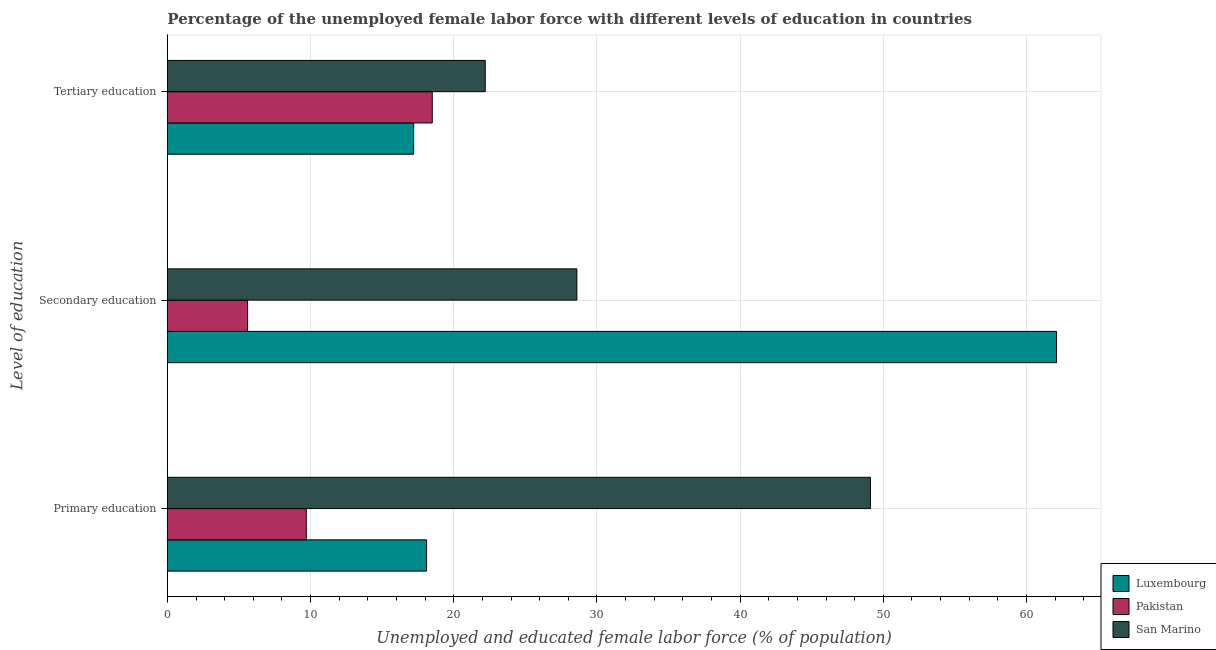How many groups of bars are there?
Your answer should be very brief. 3. Are the number of bars on each tick of the Y-axis equal?
Your answer should be very brief. Yes. What is the label of the 2nd group of bars from the top?
Give a very brief answer. Secondary education. What is the percentage of female labor force who received secondary education in San Marino?
Offer a very short reply. 28.6. Across all countries, what is the maximum percentage of female labor force who received secondary education?
Provide a succinct answer. 62.1. Across all countries, what is the minimum percentage of female labor force who received primary education?
Your answer should be compact. 9.7. In which country was the percentage of female labor force who received primary education maximum?
Provide a succinct answer. San Marino. In which country was the percentage of female labor force who received tertiary education minimum?
Ensure brevity in your answer.  Luxembourg. What is the total percentage of female labor force who received tertiary education in the graph?
Provide a short and direct response. 57.9. What is the difference between the percentage of female labor force who received secondary education in Luxembourg and that in Pakistan?
Provide a succinct answer. 56.5. What is the difference between the percentage of female labor force who received primary education in Pakistan and the percentage of female labor force who received secondary education in San Marino?
Your answer should be compact. -18.9. What is the average percentage of female labor force who received primary education per country?
Offer a very short reply. 25.63. What is the difference between the percentage of female labor force who received secondary education and percentage of female labor force who received primary education in Luxembourg?
Offer a very short reply. 44. What is the ratio of the percentage of female labor force who received secondary education in San Marino to that in Pakistan?
Keep it short and to the point. 5.11. Is the difference between the percentage of female labor force who received secondary education in Pakistan and San Marino greater than the difference between the percentage of female labor force who received primary education in Pakistan and San Marino?
Ensure brevity in your answer.  Yes. What is the difference between the highest and the second highest percentage of female labor force who received primary education?
Ensure brevity in your answer.  31. What is the difference between the highest and the lowest percentage of female labor force who received primary education?
Provide a succinct answer. 39.4. What does the 3rd bar from the top in Primary education represents?
Provide a succinct answer. Luxembourg. What does the 3rd bar from the bottom in Tertiary education represents?
Offer a very short reply. San Marino. Is it the case that in every country, the sum of the percentage of female labor force who received primary education and percentage of female labor force who received secondary education is greater than the percentage of female labor force who received tertiary education?
Offer a terse response. No. How many bars are there?
Ensure brevity in your answer.  9. How many countries are there in the graph?
Give a very brief answer. 3. What is the difference between two consecutive major ticks on the X-axis?
Provide a succinct answer. 10. Does the graph contain any zero values?
Your response must be concise. No. What is the title of the graph?
Provide a short and direct response. Percentage of the unemployed female labor force with different levels of education in countries. Does "French Polynesia" appear as one of the legend labels in the graph?
Offer a terse response. No. What is the label or title of the X-axis?
Offer a terse response. Unemployed and educated female labor force (% of population). What is the label or title of the Y-axis?
Provide a short and direct response. Level of education. What is the Unemployed and educated female labor force (% of population) in Luxembourg in Primary education?
Ensure brevity in your answer.  18.1. What is the Unemployed and educated female labor force (% of population) of Pakistan in Primary education?
Offer a very short reply. 9.7. What is the Unemployed and educated female labor force (% of population) in San Marino in Primary education?
Give a very brief answer. 49.1. What is the Unemployed and educated female labor force (% of population) of Luxembourg in Secondary education?
Provide a short and direct response. 62.1. What is the Unemployed and educated female labor force (% of population) in Pakistan in Secondary education?
Give a very brief answer. 5.6. What is the Unemployed and educated female labor force (% of population) of San Marino in Secondary education?
Ensure brevity in your answer.  28.6. What is the Unemployed and educated female labor force (% of population) of Luxembourg in Tertiary education?
Make the answer very short. 17.2. What is the Unemployed and educated female labor force (% of population) of San Marino in Tertiary education?
Your answer should be very brief. 22.2. Across all Level of education, what is the maximum Unemployed and educated female labor force (% of population) of Luxembourg?
Offer a terse response. 62.1. Across all Level of education, what is the maximum Unemployed and educated female labor force (% of population) in San Marino?
Provide a short and direct response. 49.1. Across all Level of education, what is the minimum Unemployed and educated female labor force (% of population) of Luxembourg?
Ensure brevity in your answer.  17.2. Across all Level of education, what is the minimum Unemployed and educated female labor force (% of population) of Pakistan?
Keep it short and to the point. 5.6. Across all Level of education, what is the minimum Unemployed and educated female labor force (% of population) in San Marino?
Your answer should be very brief. 22.2. What is the total Unemployed and educated female labor force (% of population) of Luxembourg in the graph?
Your answer should be compact. 97.4. What is the total Unemployed and educated female labor force (% of population) of Pakistan in the graph?
Provide a short and direct response. 33.8. What is the total Unemployed and educated female labor force (% of population) in San Marino in the graph?
Provide a short and direct response. 99.9. What is the difference between the Unemployed and educated female labor force (% of population) of Luxembourg in Primary education and that in Secondary education?
Make the answer very short. -44. What is the difference between the Unemployed and educated female labor force (% of population) of Pakistan in Primary education and that in Secondary education?
Provide a short and direct response. 4.1. What is the difference between the Unemployed and educated female labor force (% of population) in Luxembourg in Primary education and that in Tertiary education?
Ensure brevity in your answer.  0.9. What is the difference between the Unemployed and educated female labor force (% of population) in San Marino in Primary education and that in Tertiary education?
Provide a short and direct response. 26.9. What is the difference between the Unemployed and educated female labor force (% of population) in Luxembourg in Secondary education and that in Tertiary education?
Your response must be concise. 44.9. What is the difference between the Unemployed and educated female labor force (% of population) of Pakistan in Secondary education and that in Tertiary education?
Ensure brevity in your answer.  -12.9. What is the difference between the Unemployed and educated female labor force (% of population) of Luxembourg in Primary education and the Unemployed and educated female labor force (% of population) of Pakistan in Secondary education?
Provide a succinct answer. 12.5. What is the difference between the Unemployed and educated female labor force (% of population) of Pakistan in Primary education and the Unemployed and educated female labor force (% of population) of San Marino in Secondary education?
Provide a short and direct response. -18.9. What is the difference between the Unemployed and educated female labor force (% of population) in Luxembourg in Secondary education and the Unemployed and educated female labor force (% of population) in Pakistan in Tertiary education?
Offer a very short reply. 43.6. What is the difference between the Unemployed and educated female labor force (% of population) of Luxembourg in Secondary education and the Unemployed and educated female labor force (% of population) of San Marino in Tertiary education?
Your answer should be compact. 39.9. What is the difference between the Unemployed and educated female labor force (% of population) in Pakistan in Secondary education and the Unemployed and educated female labor force (% of population) in San Marino in Tertiary education?
Your response must be concise. -16.6. What is the average Unemployed and educated female labor force (% of population) in Luxembourg per Level of education?
Ensure brevity in your answer.  32.47. What is the average Unemployed and educated female labor force (% of population) of Pakistan per Level of education?
Your response must be concise. 11.27. What is the average Unemployed and educated female labor force (% of population) in San Marino per Level of education?
Offer a terse response. 33.3. What is the difference between the Unemployed and educated female labor force (% of population) of Luxembourg and Unemployed and educated female labor force (% of population) of Pakistan in Primary education?
Your answer should be very brief. 8.4. What is the difference between the Unemployed and educated female labor force (% of population) of Luxembourg and Unemployed and educated female labor force (% of population) of San Marino in Primary education?
Keep it short and to the point. -31. What is the difference between the Unemployed and educated female labor force (% of population) of Pakistan and Unemployed and educated female labor force (% of population) of San Marino in Primary education?
Provide a short and direct response. -39.4. What is the difference between the Unemployed and educated female labor force (% of population) of Luxembourg and Unemployed and educated female labor force (% of population) of Pakistan in Secondary education?
Give a very brief answer. 56.5. What is the difference between the Unemployed and educated female labor force (% of population) in Luxembourg and Unemployed and educated female labor force (% of population) in San Marino in Secondary education?
Provide a succinct answer. 33.5. What is the difference between the Unemployed and educated female labor force (% of population) of Luxembourg and Unemployed and educated female labor force (% of population) of San Marino in Tertiary education?
Your response must be concise. -5. What is the difference between the Unemployed and educated female labor force (% of population) in Pakistan and Unemployed and educated female labor force (% of population) in San Marino in Tertiary education?
Give a very brief answer. -3.7. What is the ratio of the Unemployed and educated female labor force (% of population) of Luxembourg in Primary education to that in Secondary education?
Your answer should be very brief. 0.29. What is the ratio of the Unemployed and educated female labor force (% of population) of Pakistan in Primary education to that in Secondary education?
Provide a short and direct response. 1.73. What is the ratio of the Unemployed and educated female labor force (% of population) of San Marino in Primary education to that in Secondary education?
Offer a terse response. 1.72. What is the ratio of the Unemployed and educated female labor force (% of population) of Luxembourg in Primary education to that in Tertiary education?
Your answer should be very brief. 1.05. What is the ratio of the Unemployed and educated female labor force (% of population) in Pakistan in Primary education to that in Tertiary education?
Offer a terse response. 0.52. What is the ratio of the Unemployed and educated female labor force (% of population) of San Marino in Primary education to that in Tertiary education?
Your response must be concise. 2.21. What is the ratio of the Unemployed and educated female labor force (% of population) of Luxembourg in Secondary education to that in Tertiary education?
Your response must be concise. 3.61. What is the ratio of the Unemployed and educated female labor force (% of population) of Pakistan in Secondary education to that in Tertiary education?
Offer a terse response. 0.3. What is the ratio of the Unemployed and educated female labor force (% of population) of San Marino in Secondary education to that in Tertiary education?
Your answer should be very brief. 1.29. What is the difference between the highest and the second highest Unemployed and educated female labor force (% of population) of Luxembourg?
Your answer should be very brief. 44. What is the difference between the highest and the second highest Unemployed and educated female labor force (% of population) of San Marino?
Your answer should be compact. 20.5. What is the difference between the highest and the lowest Unemployed and educated female labor force (% of population) in Luxembourg?
Offer a very short reply. 44.9. What is the difference between the highest and the lowest Unemployed and educated female labor force (% of population) of San Marino?
Your answer should be compact. 26.9. 